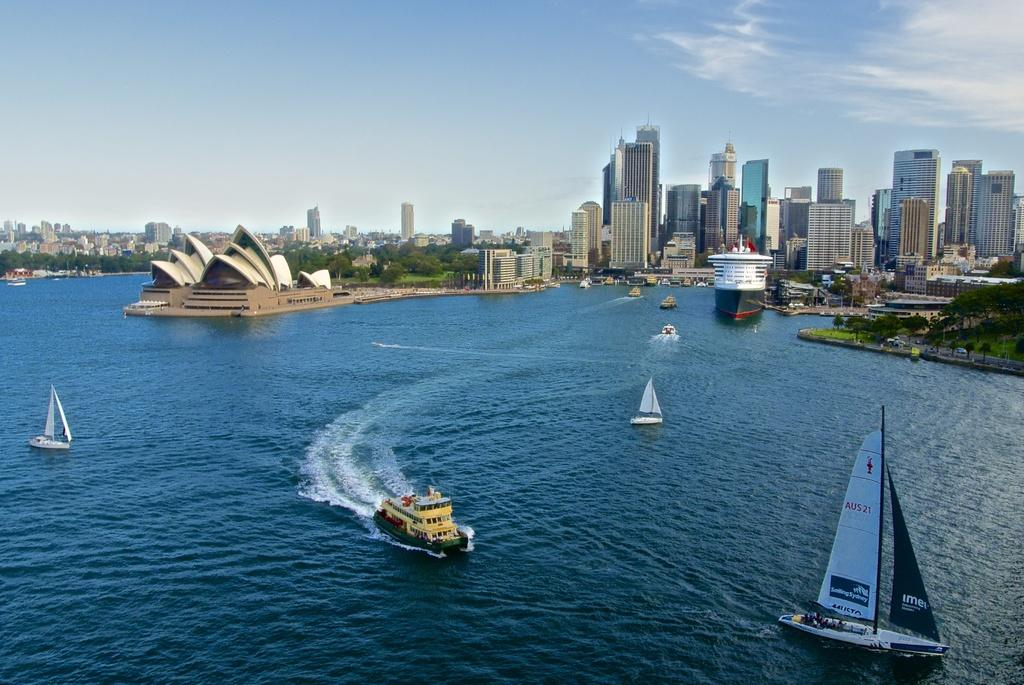What types of vehicles are in the water in the image? There are boats and ships in the water in the image. What structures and vegetation can be seen near the water? There are buildings and trees near the water. What can be seen in the sky in the background of the image? There are clouds visible in the background, and the sky is also visible. How much heat is being generated by the sun in the image? The image does not provide any information about the heat generated by the sun, as it only shows boats, ships, buildings, trees, clouds, and the sky. 